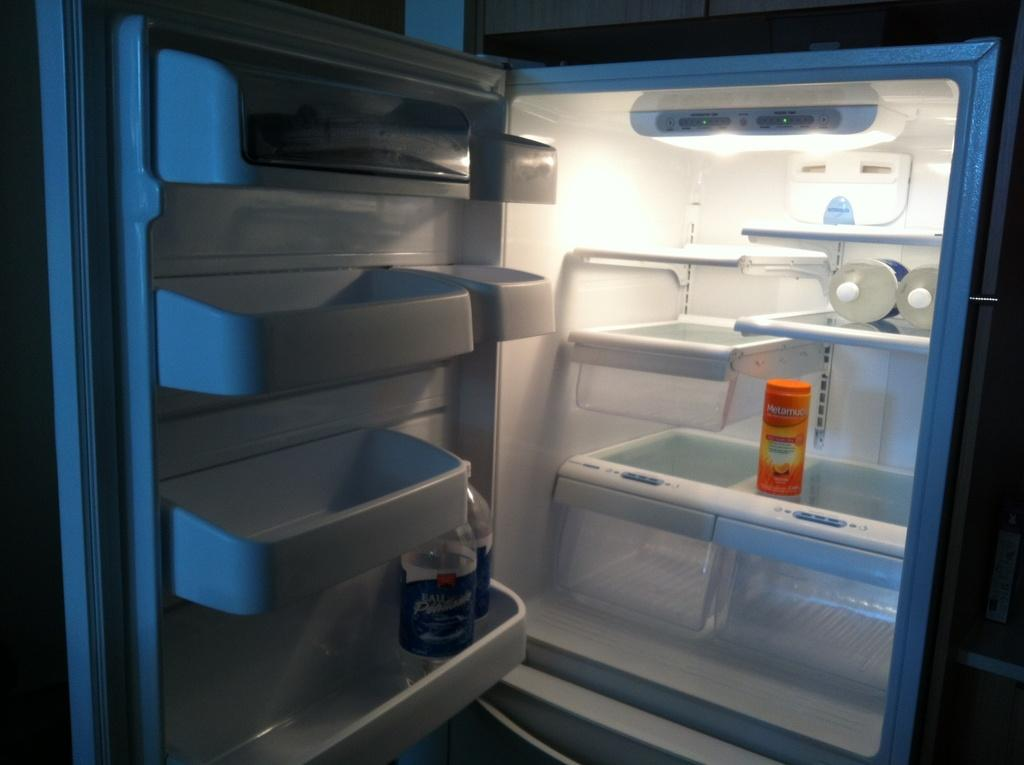<image>
Offer a succinct explanation of the picture presented. Orange container inside a fridge that says "Metamuc". 